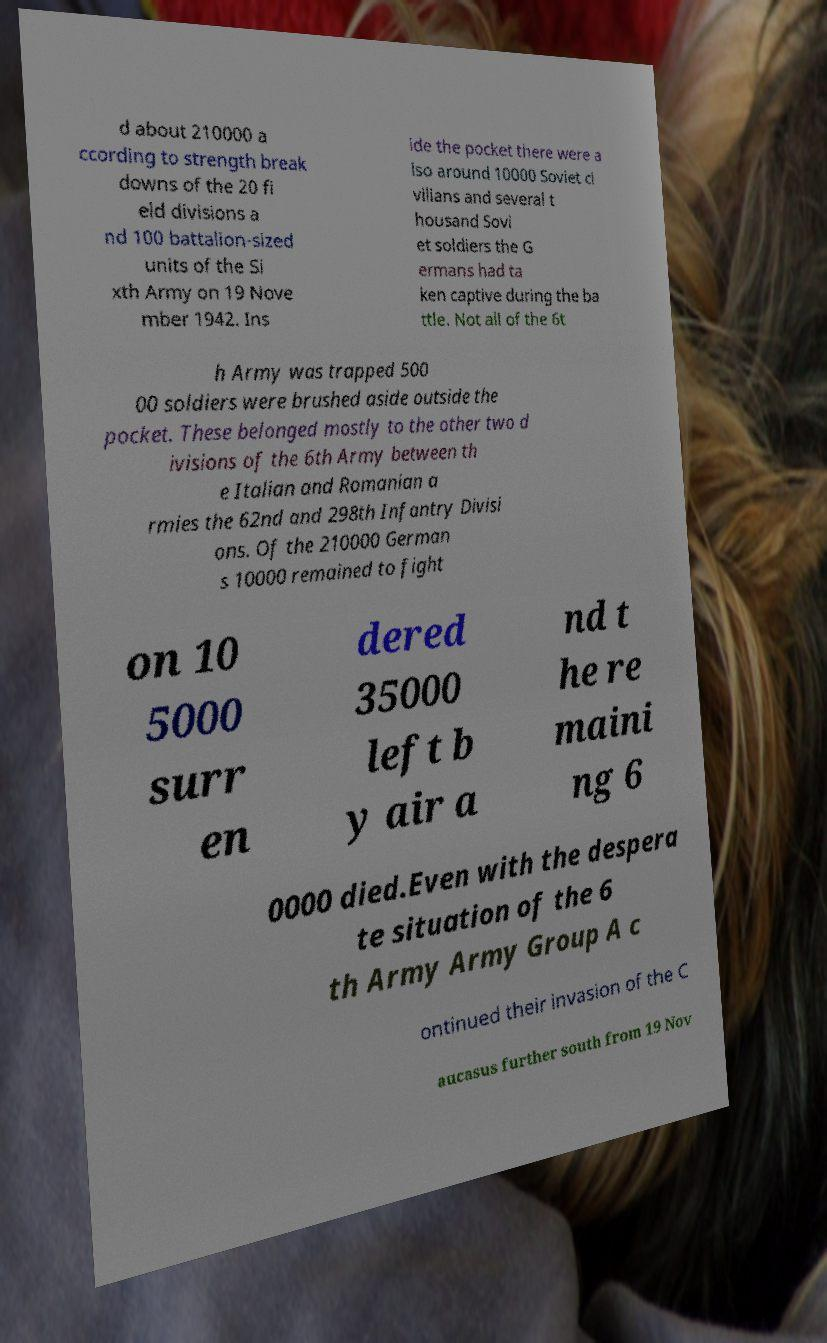Can you accurately transcribe the text from the provided image for me? d about 210000 a ccording to strength break downs of the 20 fi eld divisions a nd 100 battalion-sized units of the Si xth Army on 19 Nove mber 1942. Ins ide the pocket there were a lso around 10000 Soviet ci vilians and several t housand Sovi et soldiers the G ermans had ta ken captive during the ba ttle. Not all of the 6t h Army was trapped 500 00 soldiers were brushed aside outside the pocket. These belonged mostly to the other two d ivisions of the 6th Army between th e Italian and Romanian a rmies the 62nd and 298th Infantry Divisi ons. Of the 210000 German s 10000 remained to fight on 10 5000 surr en dered 35000 left b y air a nd t he re maini ng 6 0000 died.Even with the despera te situation of the 6 th Army Army Group A c ontinued their invasion of the C aucasus further south from 19 Nov 